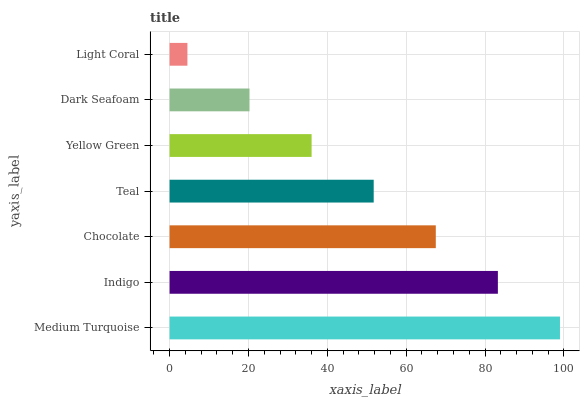Is Light Coral the minimum?
Answer yes or no. Yes. Is Medium Turquoise the maximum?
Answer yes or no. Yes. Is Indigo the minimum?
Answer yes or no. No. Is Indigo the maximum?
Answer yes or no. No. Is Medium Turquoise greater than Indigo?
Answer yes or no. Yes. Is Indigo less than Medium Turquoise?
Answer yes or no. Yes. Is Indigo greater than Medium Turquoise?
Answer yes or no. No. Is Medium Turquoise less than Indigo?
Answer yes or no. No. Is Teal the high median?
Answer yes or no. Yes. Is Teal the low median?
Answer yes or no. Yes. Is Dark Seafoam the high median?
Answer yes or no. No. Is Medium Turquoise the low median?
Answer yes or no. No. 